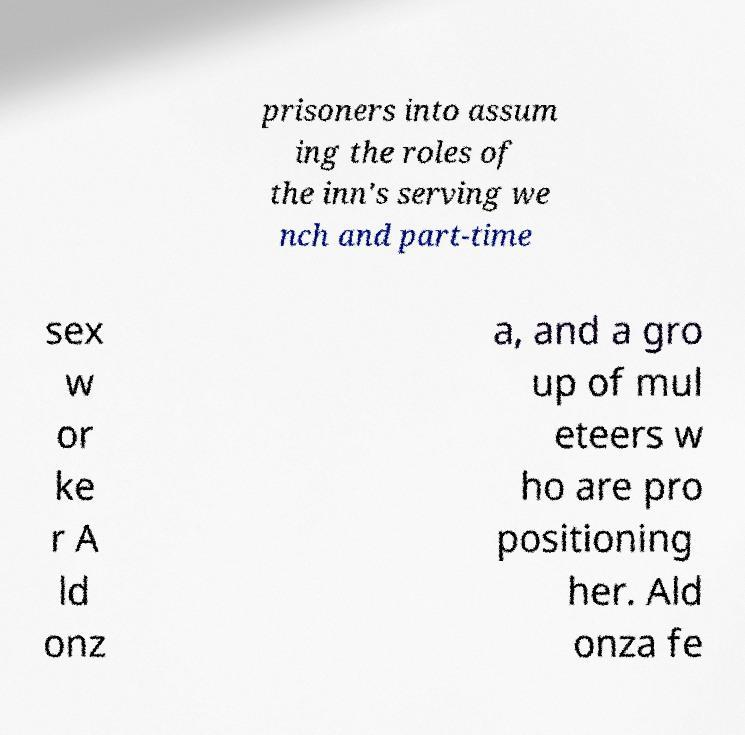Could you extract and type out the text from this image? prisoners into assum ing the roles of the inn's serving we nch and part-time sex w or ke r A ld onz a, and a gro up of mul eteers w ho are pro positioning her. Ald onza fe 